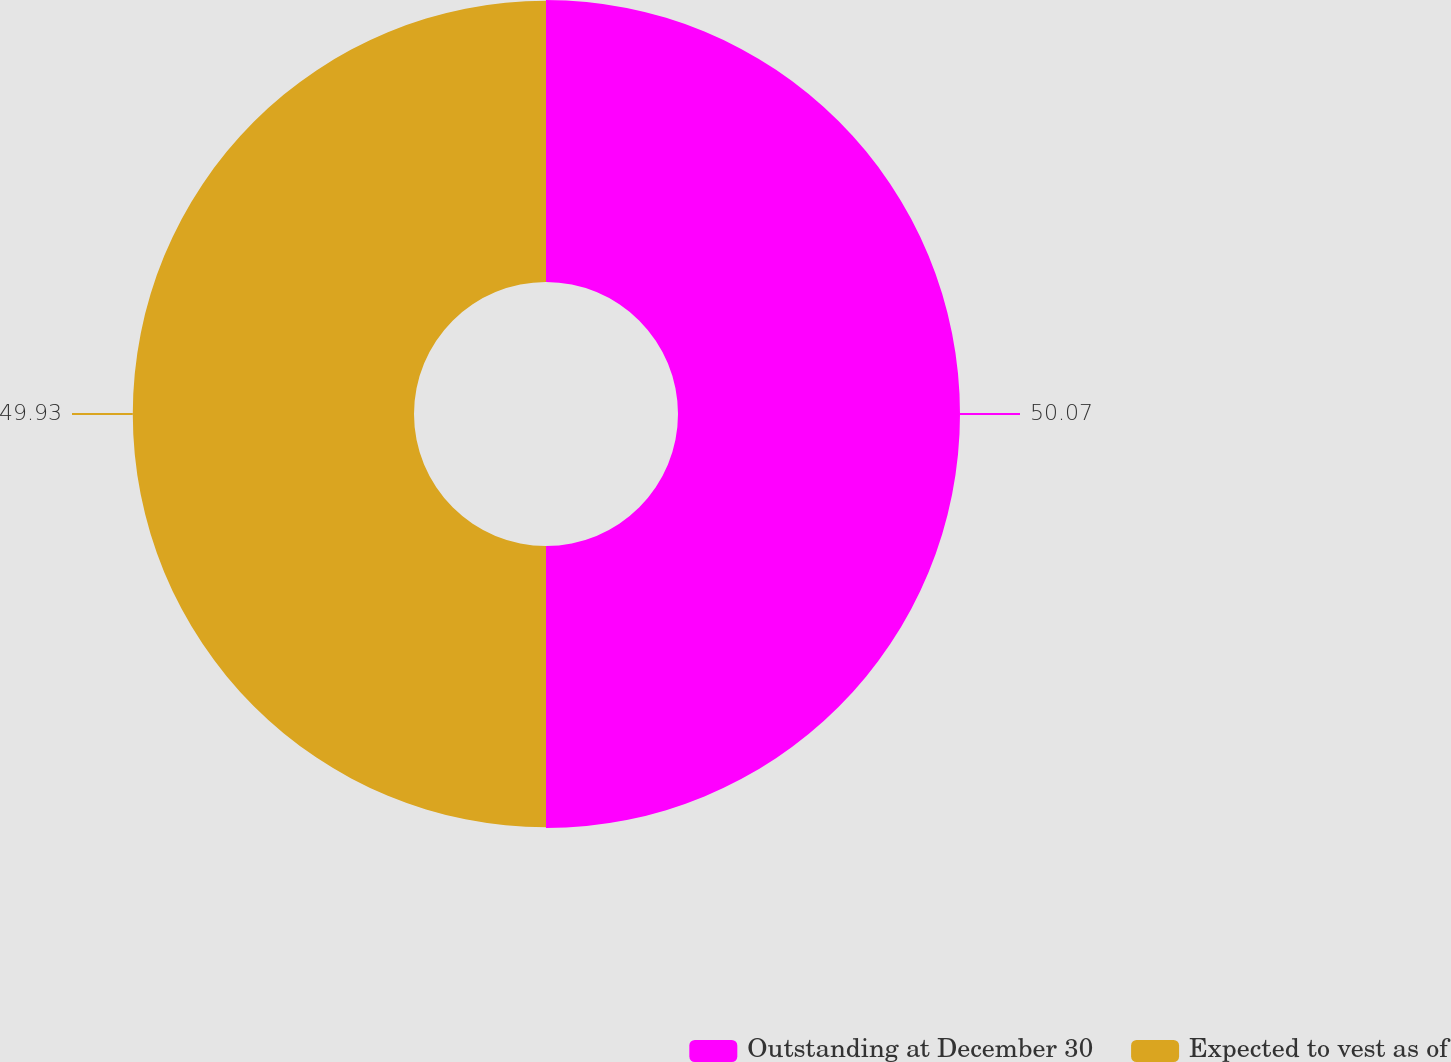<chart> <loc_0><loc_0><loc_500><loc_500><pie_chart><fcel>Outstanding at December 30<fcel>Expected to vest as of<nl><fcel>50.07%<fcel>49.93%<nl></chart> 